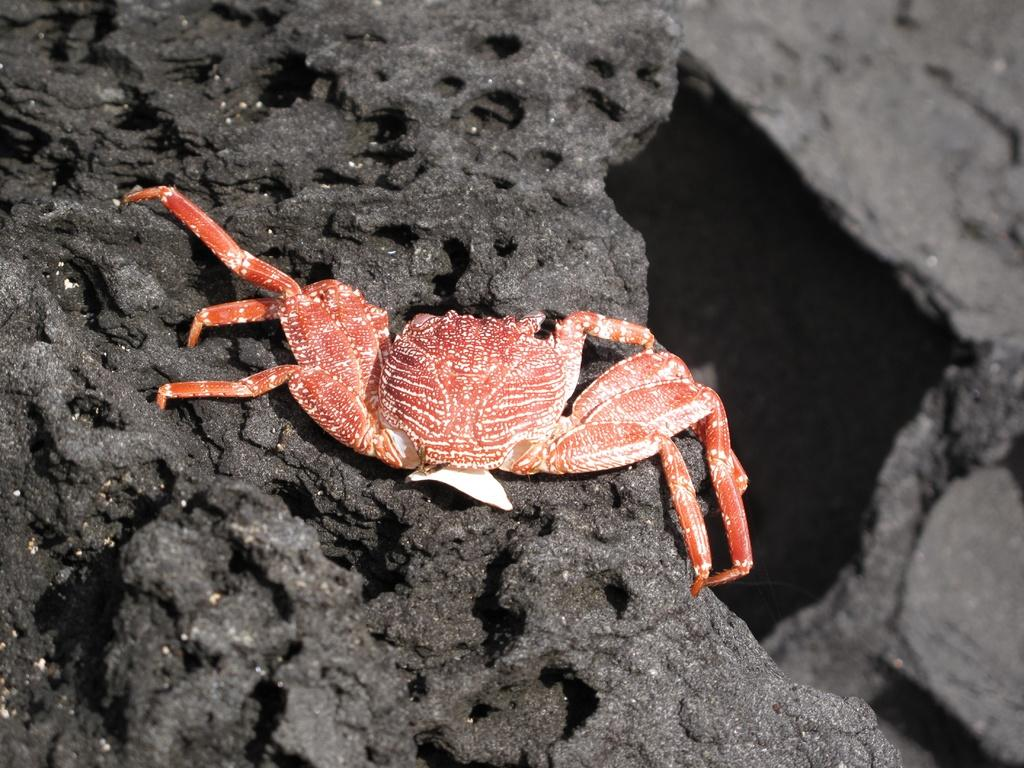What type of animal is in the image? There is an orange-colored crab in the image. What is the crab's location in the image? The crab is on a rocky surface. What color is the rocky surface? The rocky surface is black in color. What type of trousers is the crab wearing in the image? Crabs do not wear trousers, so this detail cannot be found in the image. 